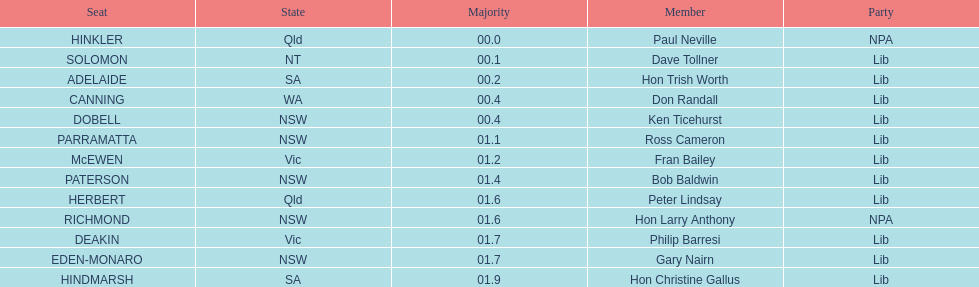How many states were included in the seats? 6. Could you help me parse every detail presented in this table? {'header': ['Seat', 'State', 'Majority', 'Member', 'Party'], 'rows': [['HINKLER', 'Qld', '00.0', 'Paul Neville', 'NPA'], ['SOLOMON', 'NT', '00.1', 'Dave Tollner', 'Lib'], ['ADELAIDE', 'SA', '00.2', 'Hon Trish Worth', 'Lib'], ['CANNING', 'WA', '00.4', 'Don Randall', 'Lib'], ['DOBELL', 'NSW', '00.4', 'Ken Ticehurst', 'Lib'], ['PARRAMATTA', 'NSW', '01.1', 'Ross Cameron', 'Lib'], ['McEWEN', 'Vic', '01.2', 'Fran Bailey', 'Lib'], ['PATERSON', 'NSW', '01.4', 'Bob Baldwin', 'Lib'], ['HERBERT', 'Qld', '01.6', 'Peter Lindsay', 'Lib'], ['RICHMOND', 'NSW', '01.6', 'Hon Larry Anthony', 'NPA'], ['DEAKIN', 'Vic', '01.7', 'Philip Barresi', 'Lib'], ['EDEN-MONARO', 'NSW', '01.7', 'Gary Nairn', 'Lib'], ['HINDMARSH', 'SA', '01.9', 'Hon Christine Gallus', 'Lib']]} 